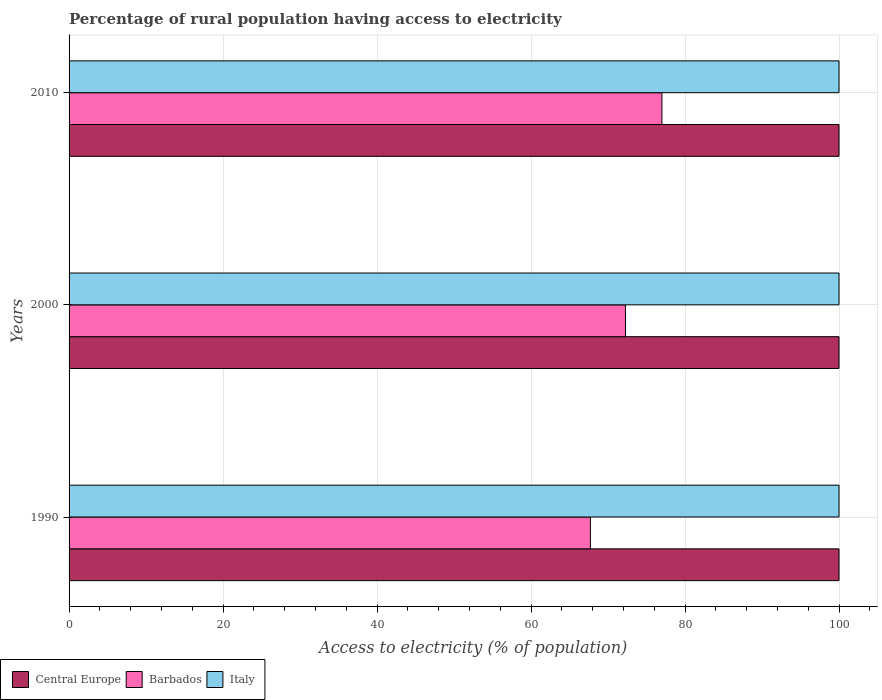How many different coloured bars are there?
Keep it short and to the point. 3. Are the number of bars per tick equal to the number of legend labels?
Make the answer very short. Yes. How many bars are there on the 2nd tick from the top?
Your answer should be compact. 3. How many bars are there on the 1st tick from the bottom?
Your response must be concise. 3. What is the label of the 3rd group of bars from the top?
Your response must be concise. 1990. What is the percentage of rural population having access to electricity in Italy in 2010?
Your answer should be compact. 100. Across all years, what is the maximum percentage of rural population having access to electricity in Central Europe?
Provide a short and direct response. 100. Across all years, what is the minimum percentage of rural population having access to electricity in Italy?
Keep it short and to the point. 100. What is the total percentage of rural population having access to electricity in Central Europe in the graph?
Provide a succinct answer. 300. What is the difference between the percentage of rural population having access to electricity in Barbados in 1990 and that in 2000?
Provide a short and direct response. -4.55. What is the difference between the percentage of rural population having access to electricity in Central Europe in 1990 and the percentage of rural population having access to electricity in Italy in 2010?
Provide a succinct answer. 0. What is the average percentage of rural population having access to electricity in Barbados per year?
Offer a terse response. 72.33. In the year 2010, what is the difference between the percentage of rural population having access to electricity in Italy and percentage of rural population having access to electricity in Central Europe?
Keep it short and to the point. 0. In how many years, is the percentage of rural population having access to electricity in Central Europe greater than 4 %?
Your response must be concise. 3. Is the percentage of rural population having access to electricity in Italy in 2000 less than that in 2010?
Your answer should be compact. No. What is the difference between the highest and the lowest percentage of rural population having access to electricity in Central Europe?
Offer a very short reply. 0. In how many years, is the percentage of rural population having access to electricity in Italy greater than the average percentage of rural population having access to electricity in Italy taken over all years?
Make the answer very short. 0. What does the 3rd bar from the top in 2000 represents?
Offer a very short reply. Central Europe. What does the 2nd bar from the bottom in 1990 represents?
Ensure brevity in your answer.  Barbados. Is it the case that in every year, the sum of the percentage of rural population having access to electricity in Central Europe and percentage of rural population having access to electricity in Barbados is greater than the percentage of rural population having access to electricity in Italy?
Your response must be concise. Yes. Does the graph contain grids?
Your response must be concise. Yes. What is the title of the graph?
Offer a terse response. Percentage of rural population having access to electricity. What is the label or title of the X-axis?
Provide a succinct answer. Access to electricity (% of population). What is the Access to electricity (% of population) of Barbados in 1990?
Keep it short and to the point. 67.71. What is the Access to electricity (% of population) in Italy in 1990?
Your response must be concise. 100. What is the Access to electricity (% of population) in Barbados in 2000?
Ensure brevity in your answer.  72.27. What is the Access to electricity (% of population) in Central Europe in 2010?
Your answer should be compact. 100. What is the Access to electricity (% of population) in Barbados in 2010?
Make the answer very short. 77. Across all years, what is the maximum Access to electricity (% of population) of Barbados?
Your answer should be very brief. 77. Across all years, what is the minimum Access to electricity (% of population) of Barbados?
Keep it short and to the point. 67.71. Across all years, what is the minimum Access to electricity (% of population) of Italy?
Provide a succinct answer. 100. What is the total Access to electricity (% of population) in Central Europe in the graph?
Keep it short and to the point. 300. What is the total Access to electricity (% of population) in Barbados in the graph?
Make the answer very short. 216.98. What is the total Access to electricity (% of population) of Italy in the graph?
Give a very brief answer. 300. What is the difference between the Access to electricity (% of population) of Barbados in 1990 and that in 2000?
Make the answer very short. -4.55. What is the difference between the Access to electricity (% of population) in Barbados in 1990 and that in 2010?
Make the answer very short. -9.29. What is the difference between the Access to electricity (% of population) of Italy in 1990 and that in 2010?
Give a very brief answer. 0. What is the difference between the Access to electricity (% of population) in Central Europe in 2000 and that in 2010?
Provide a short and direct response. 0. What is the difference between the Access to electricity (% of population) of Barbados in 2000 and that in 2010?
Your response must be concise. -4.74. What is the difference between the Access to electricity (% of population) of Central Europe in 1990 and the Access to electricity (% of population) of Barbados in 2000?
Give a very brief answer. 27.73. What is the difference between the Access to electricity (% of population) in Central Europe in 1990 and the Access to electricity (% of population) in Italy in 2000?
Your answer should be very brief. 0. What is the difference between the Access to electricity (% of population) in Barbados in 1990 and the Access to electricity (% of population) in Italy in 2000?
Keep it short and to the point. -32.29. What is the difference between the Access to electricity (% of population) of Central Europe in 1990 and the Access to electricity (% of population) of Barbados in 2010?
Give a very brief answer. 23. What is the difference between the Access to electricity (% of population) of Central Europe in 1990 and the Access to electricity (% of population) of Italy in 2010?
Your response must be concise. 0. What is the difference between the Access to electricity (% of population) in Barbados in 1990 and the Access to electricity (% of population) in Italy in 2010?
Offer a terse response. -32.29. What is the difference between the Access to electricity (% of population) of Barbados in 2000 and the Access to electricity (% of population) of Italy in 2010?
Ensure brevity in your answer.  -27.73. What is the average Access to electricity (% of population) in Barbados per year?
Make the answer very short. 72.33. What is the average Access to electricity (% of population) in Italy per year?
Offer a terse response. 100. In the year 1990, what is the difference between the Access to electricity (% of population) in Central Europe and Access to electricity (% of population) in Barbados?
Make the answer very short. 32.29. In the year 1990, what is the difference between the Access to electricity (% of population) of Central Europe and Access to electricity (% of population) of Italy?
Give a very brief answer. 0. In the year 1990, what is the difference between the Access to electricity (% of population) in Barbados and Access to electricity (% of population) in Italy?
Offer a terse response. -32.29. In the year 2000, what is the difference between the Access to electricity (% of population) of Central Europe and Access to electricity (% of population) of Barbados?
Offer a terse response. 27.73. In the year 2000, what is the difference between the Access to electricity (% of population) in Barbados and Access to electricity (% of population) in Italy?
Your answer should be very brief. -27.73. In the year 2010, what is the difference between the Access to electricity (% of population) in Central Europe and Access to electricity (% of population) in Barbados?
Make the answer very short. 23. In the year 2010, what is the difference between the Access to electricity (% of population) in Central Europe and Access to electricity (% of population) in Italy?
Keep it short and to the point. 0. What is the ratio of the Access to electricity (% of population) in Barbados in 1990 to that in 2000?
Give a very brief answer. 0.94. What is the ratio of the Access to electricity (% of population) of Barbados in 1990 to that in 2010?
Provide a short and direct response. 0.88. What is the ratio of the Access to electricity (% of population) of Italy in 1990 to that in 2010?
Your answer should be very brief. 1. What is the ratio of the Access to electricity (% of population) in Central Europe in 2000 to that in 2010?
Keep it short and to the point. 1. What is the ratio of the Access to electricity (% of population) of Barbados in 2000 to that in 2010?
Offer a very short reply. 0.94. What is the ratio of the Access to electricity (% of population) in Italy in 2000 to that in 2010?
Make the answer very short. 1. What is the difference between the highest and the second highest Access to electricity (% of population) in Central Europe?
Your answer should be compact. 0. What is the difference between the highest and the second highest Access to electricity (% of population) of Barbados?
Ensure brevity in your answer.  4.74. What is the difference between the highest and the lowest Access to electricity (% of population) in Barbados?
Keep it short and to the point. 9.29. What is the difference between the highest and the lowest Access to electricity (% of population) in Italy?
Give a very brief answer. 0. 